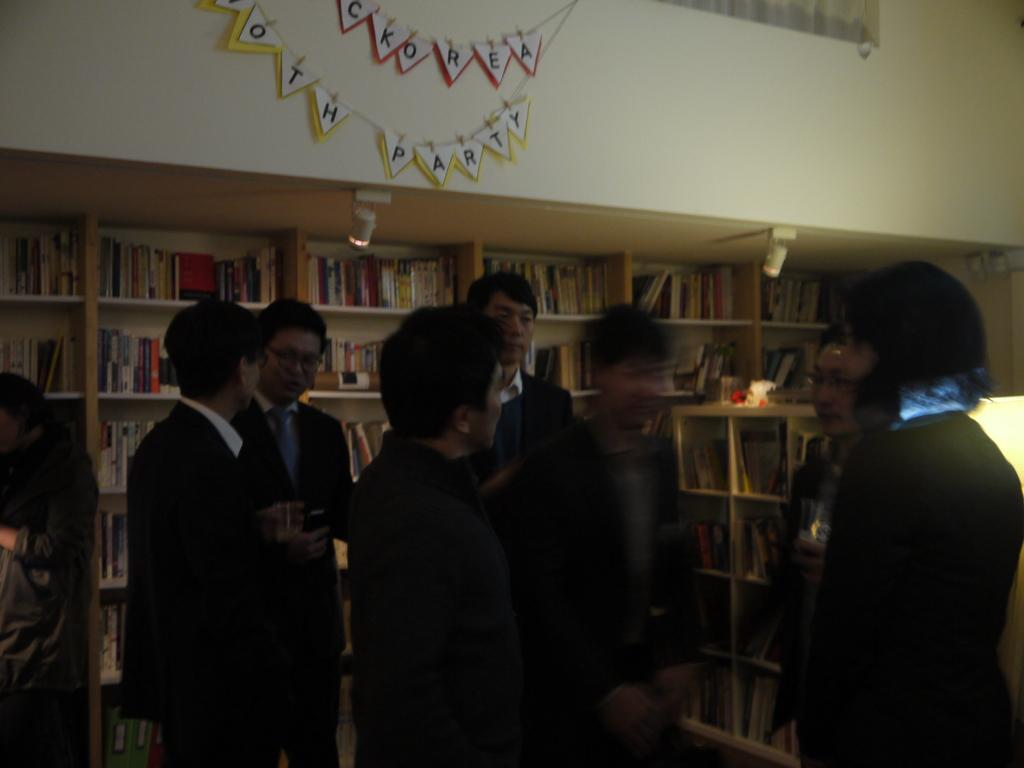What type of clothing are the men in the image wearing? The men in the image are wearing suits. Where are the men positioned in the image? The men are standing in the front. What can be seen behind the men in the image? There are racks with books behind the men. What decorative items are present on the wall in the image? There are party ribbons on the wall in the image. What type of planes are flying in the image? There are no planes visible in the image. Can you read the note that the man is holding in the image? There is no note present in the image. 